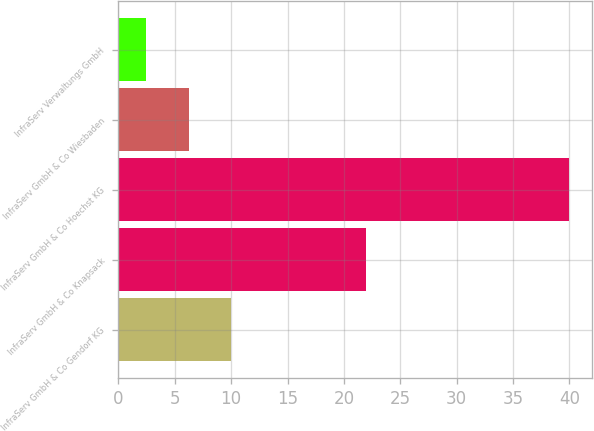Convert chart to OTSL. <chart><loc_0><loc_0><loc_500><loc_500><bar_chart><fcel>InfraServ GmbH & Co Gendorf KG<fcel>InfraServ GmbH & Co Knapsack<fcel>InfraServ GmbH & Co Hoechst KG<fcel>InfraServ GmbH & Co Wiesbaden<fcel>InfraServ Verwaltungs GmbH<nl><fcel>10<fcel>22<fcel>40<fcel>6.23<fcel>2.48<nl></chart> 